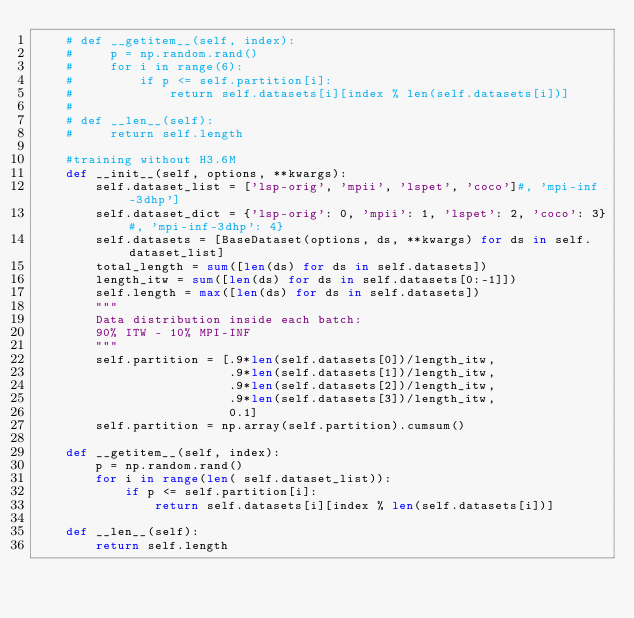<code> <loc_0><loc_0><loc_500><loc_500><_Python_>    # def __getitem__(self, index):
    #     p = np.random.rand()
    #     for i in range(6):
    #         if p <= self.partition[i]:
    #             return self.datasets[i][index % len(self.datasets[i])]
    #
    # def __len__(self):
    #     return self.length

    #training without H3.6M
    def __init__(self, options, **kwargs):
        self.dataset_list = ['lsp-orig', 'mpii', 'lspet', 'coco']#, 'mpi-inf-3dhp']
        self.dataset_dict = {'lsp-orig': 0, 'mpii': 1, 'lspet': 2, 'coco': 3}#, 'mpi-inf-3dhp': 4}
        self.datasets = [BaseDataset(options, ds, **kwargs) for ds in self.dataset_list]
        total_length = sum([len(ds) for ds in self.datasets])
        length_itw = sum([len(ds) for ds in self.datasets[0:-1]])
        self.length = max([len(ds) for ds in self.datasets])
        """
        Data distribution inside each batch:
        90% ITW - 10% MPI-INF
        """
        self.partition = [.9*len(self.datasets[0])/length_itw,
                          .9*len(self.datasets[1])/length_itw,
                          .9*len(self.datasets[2])/length_itw,
                          .9*len(self.datasets[3])/length_itw,
                          0.1]
        self.partition = np.array(self.partition).cumsum()

    def __getitem__(self, index):
        p = np.random.rand()
        for i in range(len( self.dataset_list)):
            if p <= self.partition[i]:
                return self.datasets[i][index % len(self.datasets[i])]

    def __len__(self):
        return self.length</code> 